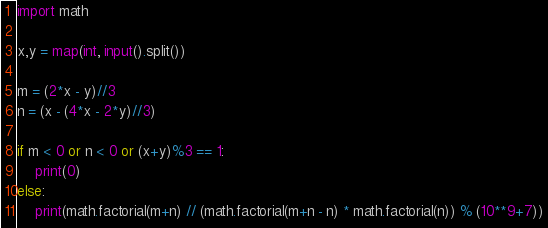Convert code to text. <code><loc_0><loc_0><loc_500><loc_500><_Python_>import math

x,y = map(int, input().split())

m = (2*x - y)//3
n = (x - (4*x - 2*y)//3)

if m < 0 or n < 0 or (x+y)%3 == 1:
	print(0)
else:
	print(math.factorial(m+n) // (math.factorial(m+n - n) * math.factorial(n)) % (10**9+7))</code> 